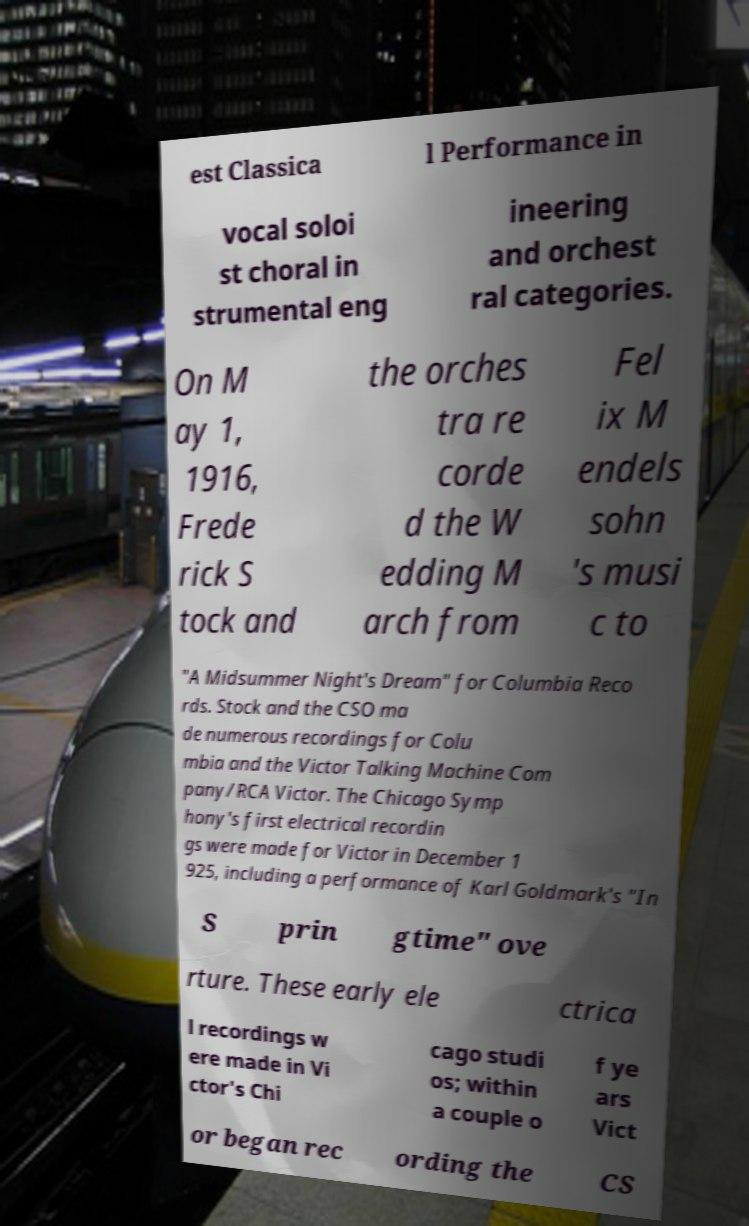Please read and relay the text visible in this image. What does it say? est Classica l Performance in vocal soloi st choral in strumental eng ineering and orchest ral categories. On M ay 1, 1916, Frede rick S tock and the orches tra re corde d the W edding M arch from Fel ix M endels sohn 's musi c to "A Midsummer Night's Dream" for Columbia Reco rds. Stock and the CSO ma de numerous recordings for Colu mbia and the Victor Talking Machine Com pany/RCA Victor. The Chicago Symp hony's first electrical recordin gs were made for Victor in December 1 925, including a performance of Karl Goldmark's "In S prin gtime" ove rture. These early ele ctrica l recordings w ere made in Vi ctor's Chi cago studi os; within a couple o f ye ars Vict or began rec ording the CS 